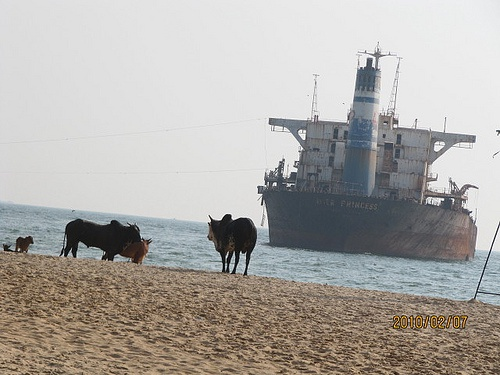Describe the objects in this image and their specific colors. I can see boat in lightgray, gray, darkblue, and darkgray tones, cow in lightgray, black, gray, and darkgray tones, cow in lightgray, black, gray, and darkgray tones, cow in lightgray, black, maroon, and gray tones, and cow in lightgray, black, and gray tones in this image. 